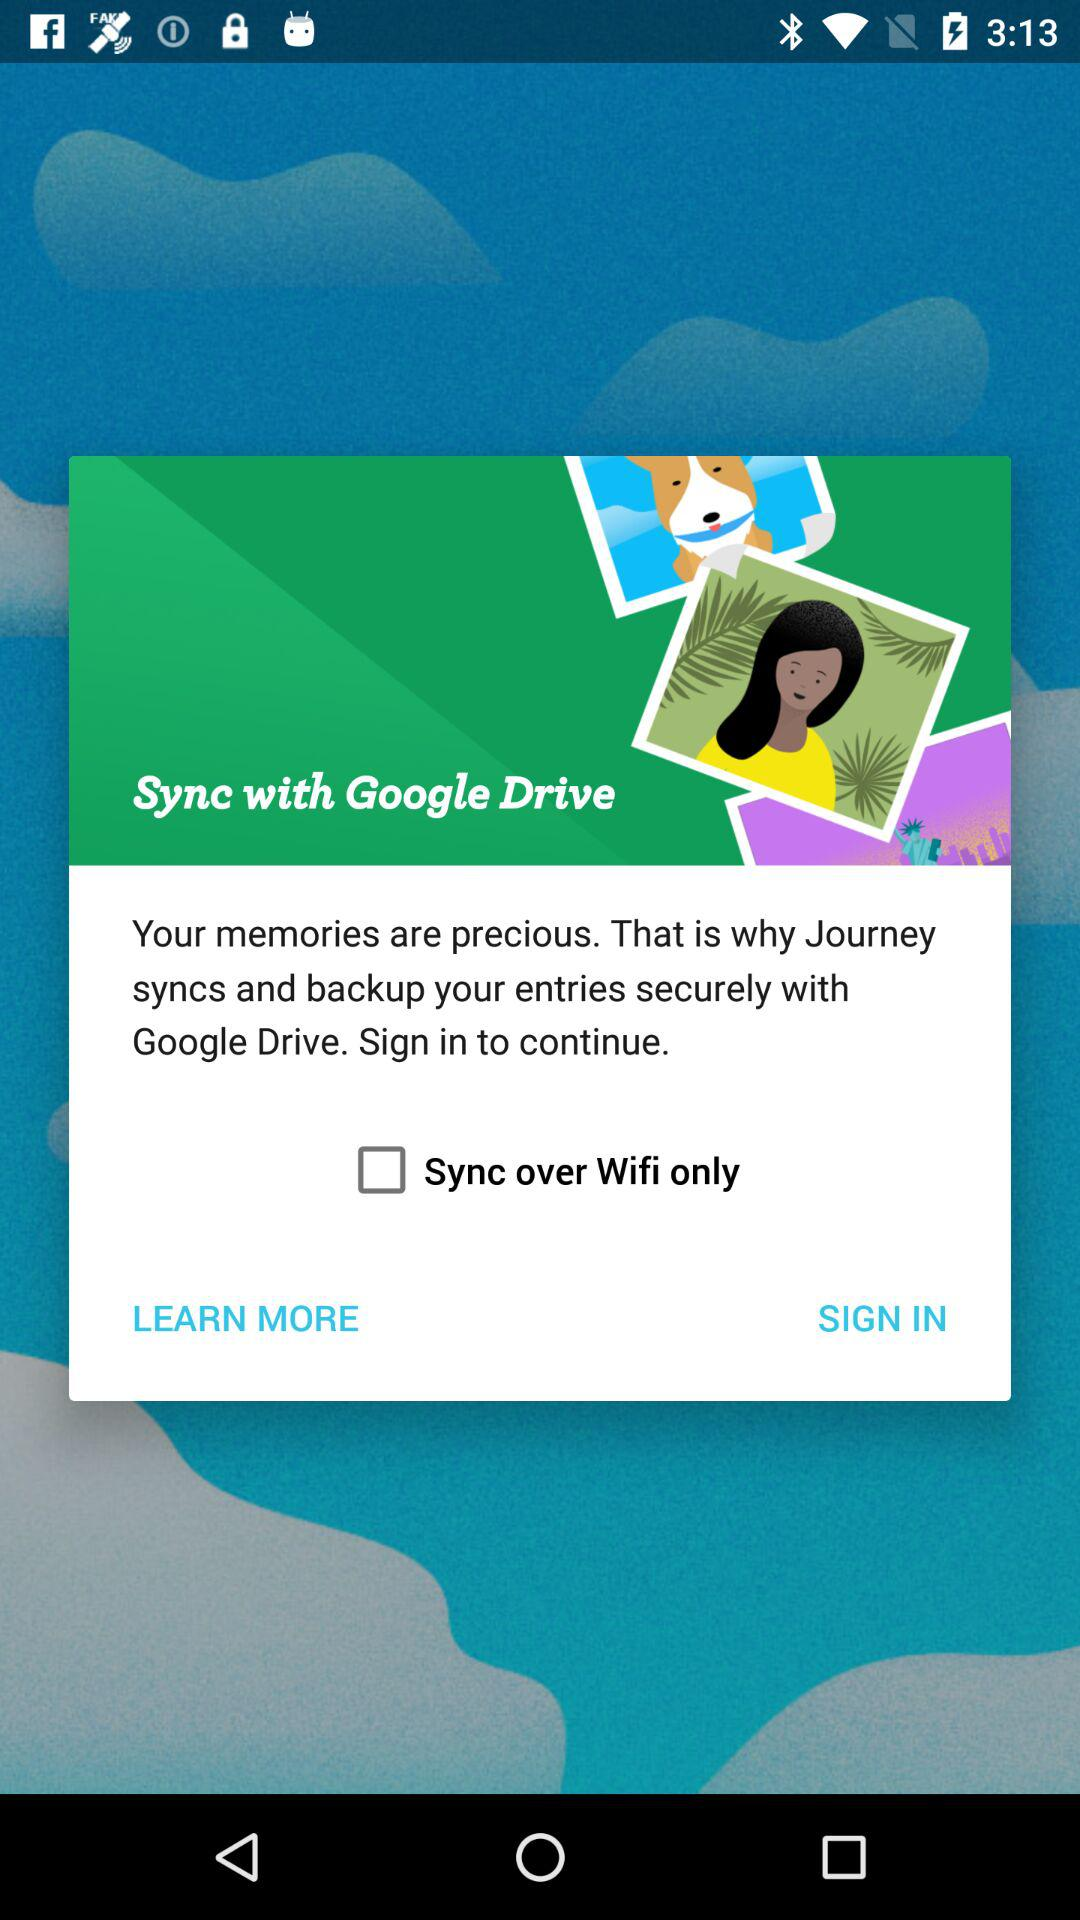What option of Wifi is unchecked? The option is "Sync over Wifi only". 